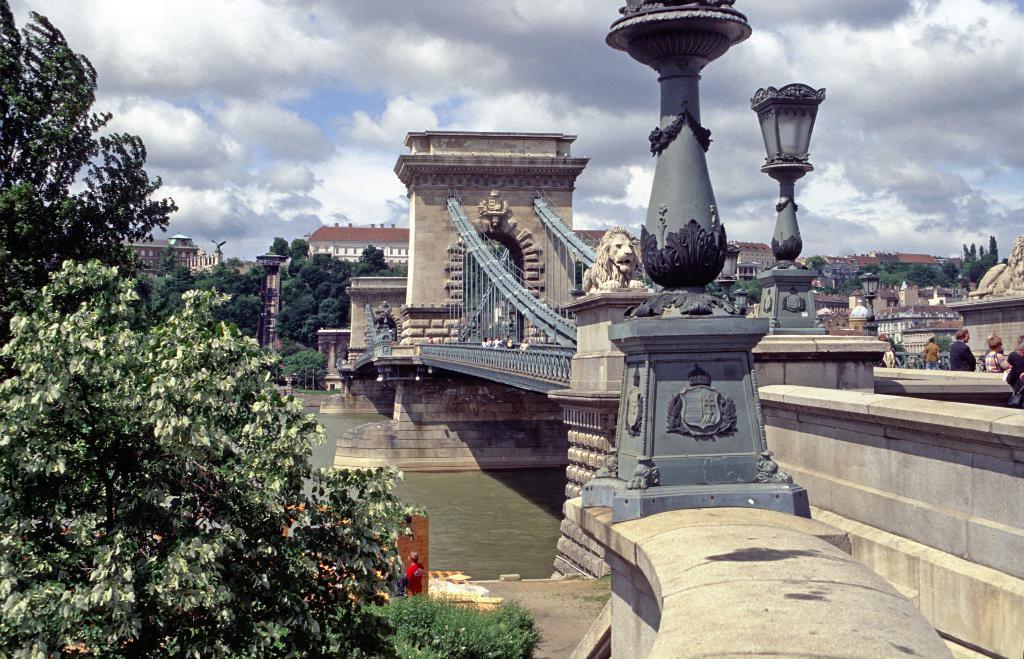Describe this image in one or two sentences. In this image, at the left side there are some green color trees, there is a bridge and there is a river at the bottom, at the right side there are some people standing, at the top there is a sky which is cloudy. 